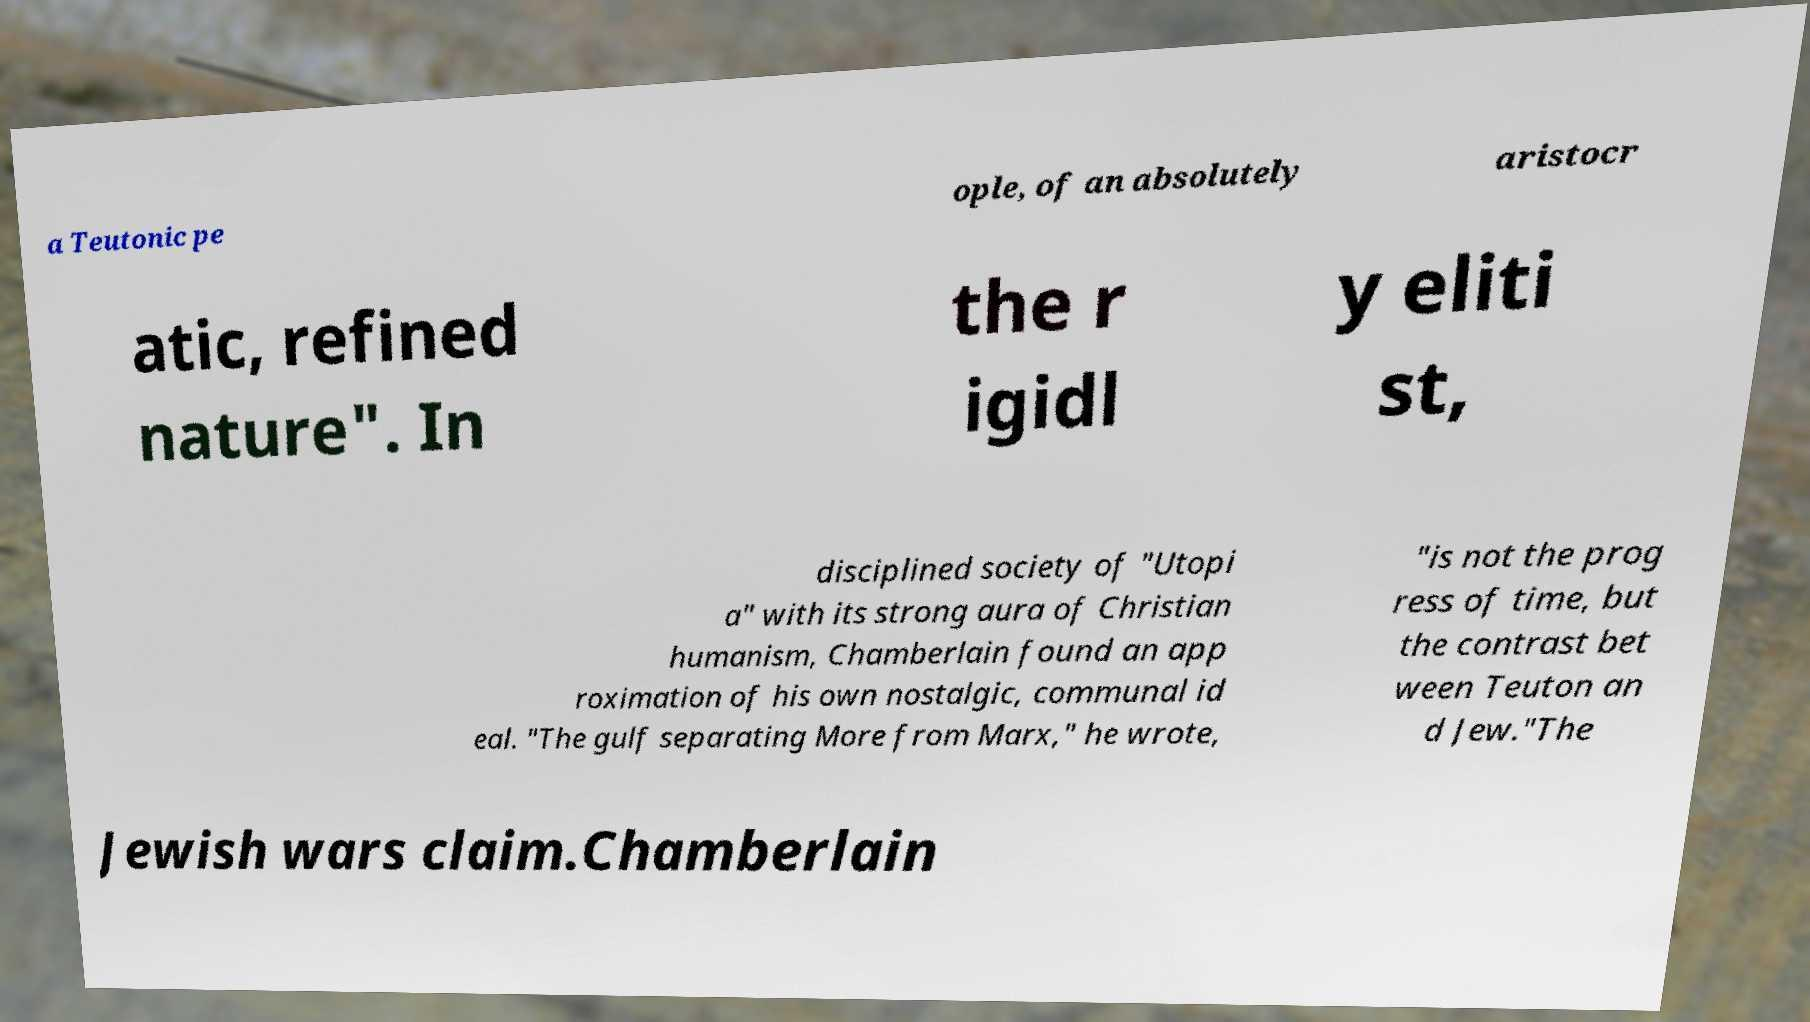For documentation purposes, I need the text within this image transcribed. Could you provide that? a Teutonic pe ople, of an absolutely aristocr atic, refined nature". In the r igidl y eliti st, disciplined society of "Utopi a" with its strong aura of Christian humanism, Chamberlain found an app roximation of his own nostalgic, communal id eal. "The gulf separating More from Marx," he wrote, "is not the prog ress of time, but the contrast bet ween Teuton an d Jew."The Jewish wars claim.Chamberlain 